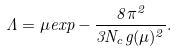<formula> <loc_0><loc_0><loc_500><loc_500>\Lambda = \mu e x p - \frac { 8 \pi ^ { 2 } } { 3 N _ { c } g ( \mu ) ^ { 2 } } .</formula> 